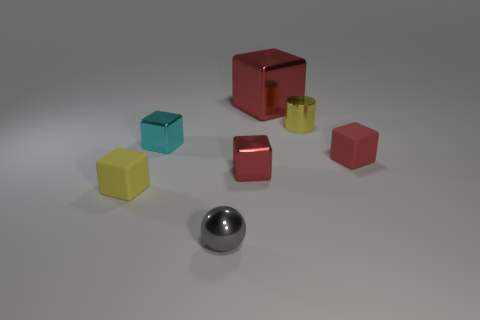Subtract all red blocks. How many were subtracted if there are1red blocks left? 2 Subtract all purple balls. How many red blocks are left? 3 Subtract 2 cubes. How many cubes are left? 3 Subtract all tiny cyan metal cubes. How many cubes are left? 4 Subtract all yellow cubes. How many cubes are left? 4 Subtract all green cubes. Subtract all purple spheres. How many cubes are left? 5 Add 1 gray metal balls. How many objects exist? 8 Subtract 0 brown cylinders. How many objects are left? 7 Subtract all cylinders. How many objects are left? 6 Subtract all tiny yellow metal cylinders. Subtract all tiny matte cubes. How many objects are left? 4 